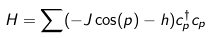<formula> <loc_0><loc_0><loc_500><loc_500>H = \sum ( - J \cos ( p ) - h ) c ^ { \dagger } _ { p } c _ { p }</formula> 